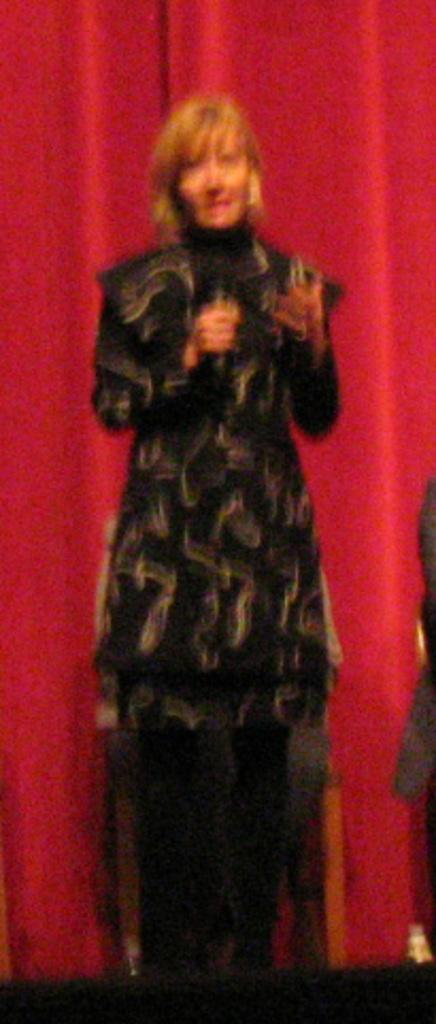Who is present in the image? There is a woman in the image. What is the woman doing in the image? The woman is standing in the image. What is the woman wearing? The woman is wearing clothes in the image. What can be seen on the floor in the image? There is a red carpet in the image. How many parcels can be seen on the red carpet in the image? There are no parcels present in the image; only a woman and a red carpet are visible. Can you spot any ants crawling on the woman's clothes in the image? There are no ants visible in the image. 